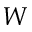<formula> <loc_0><loc_0><loc_500><loc_500>W</formula> 